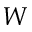<formula> <loc_0><loc_0><loc_500><loc_500>W</formula> 